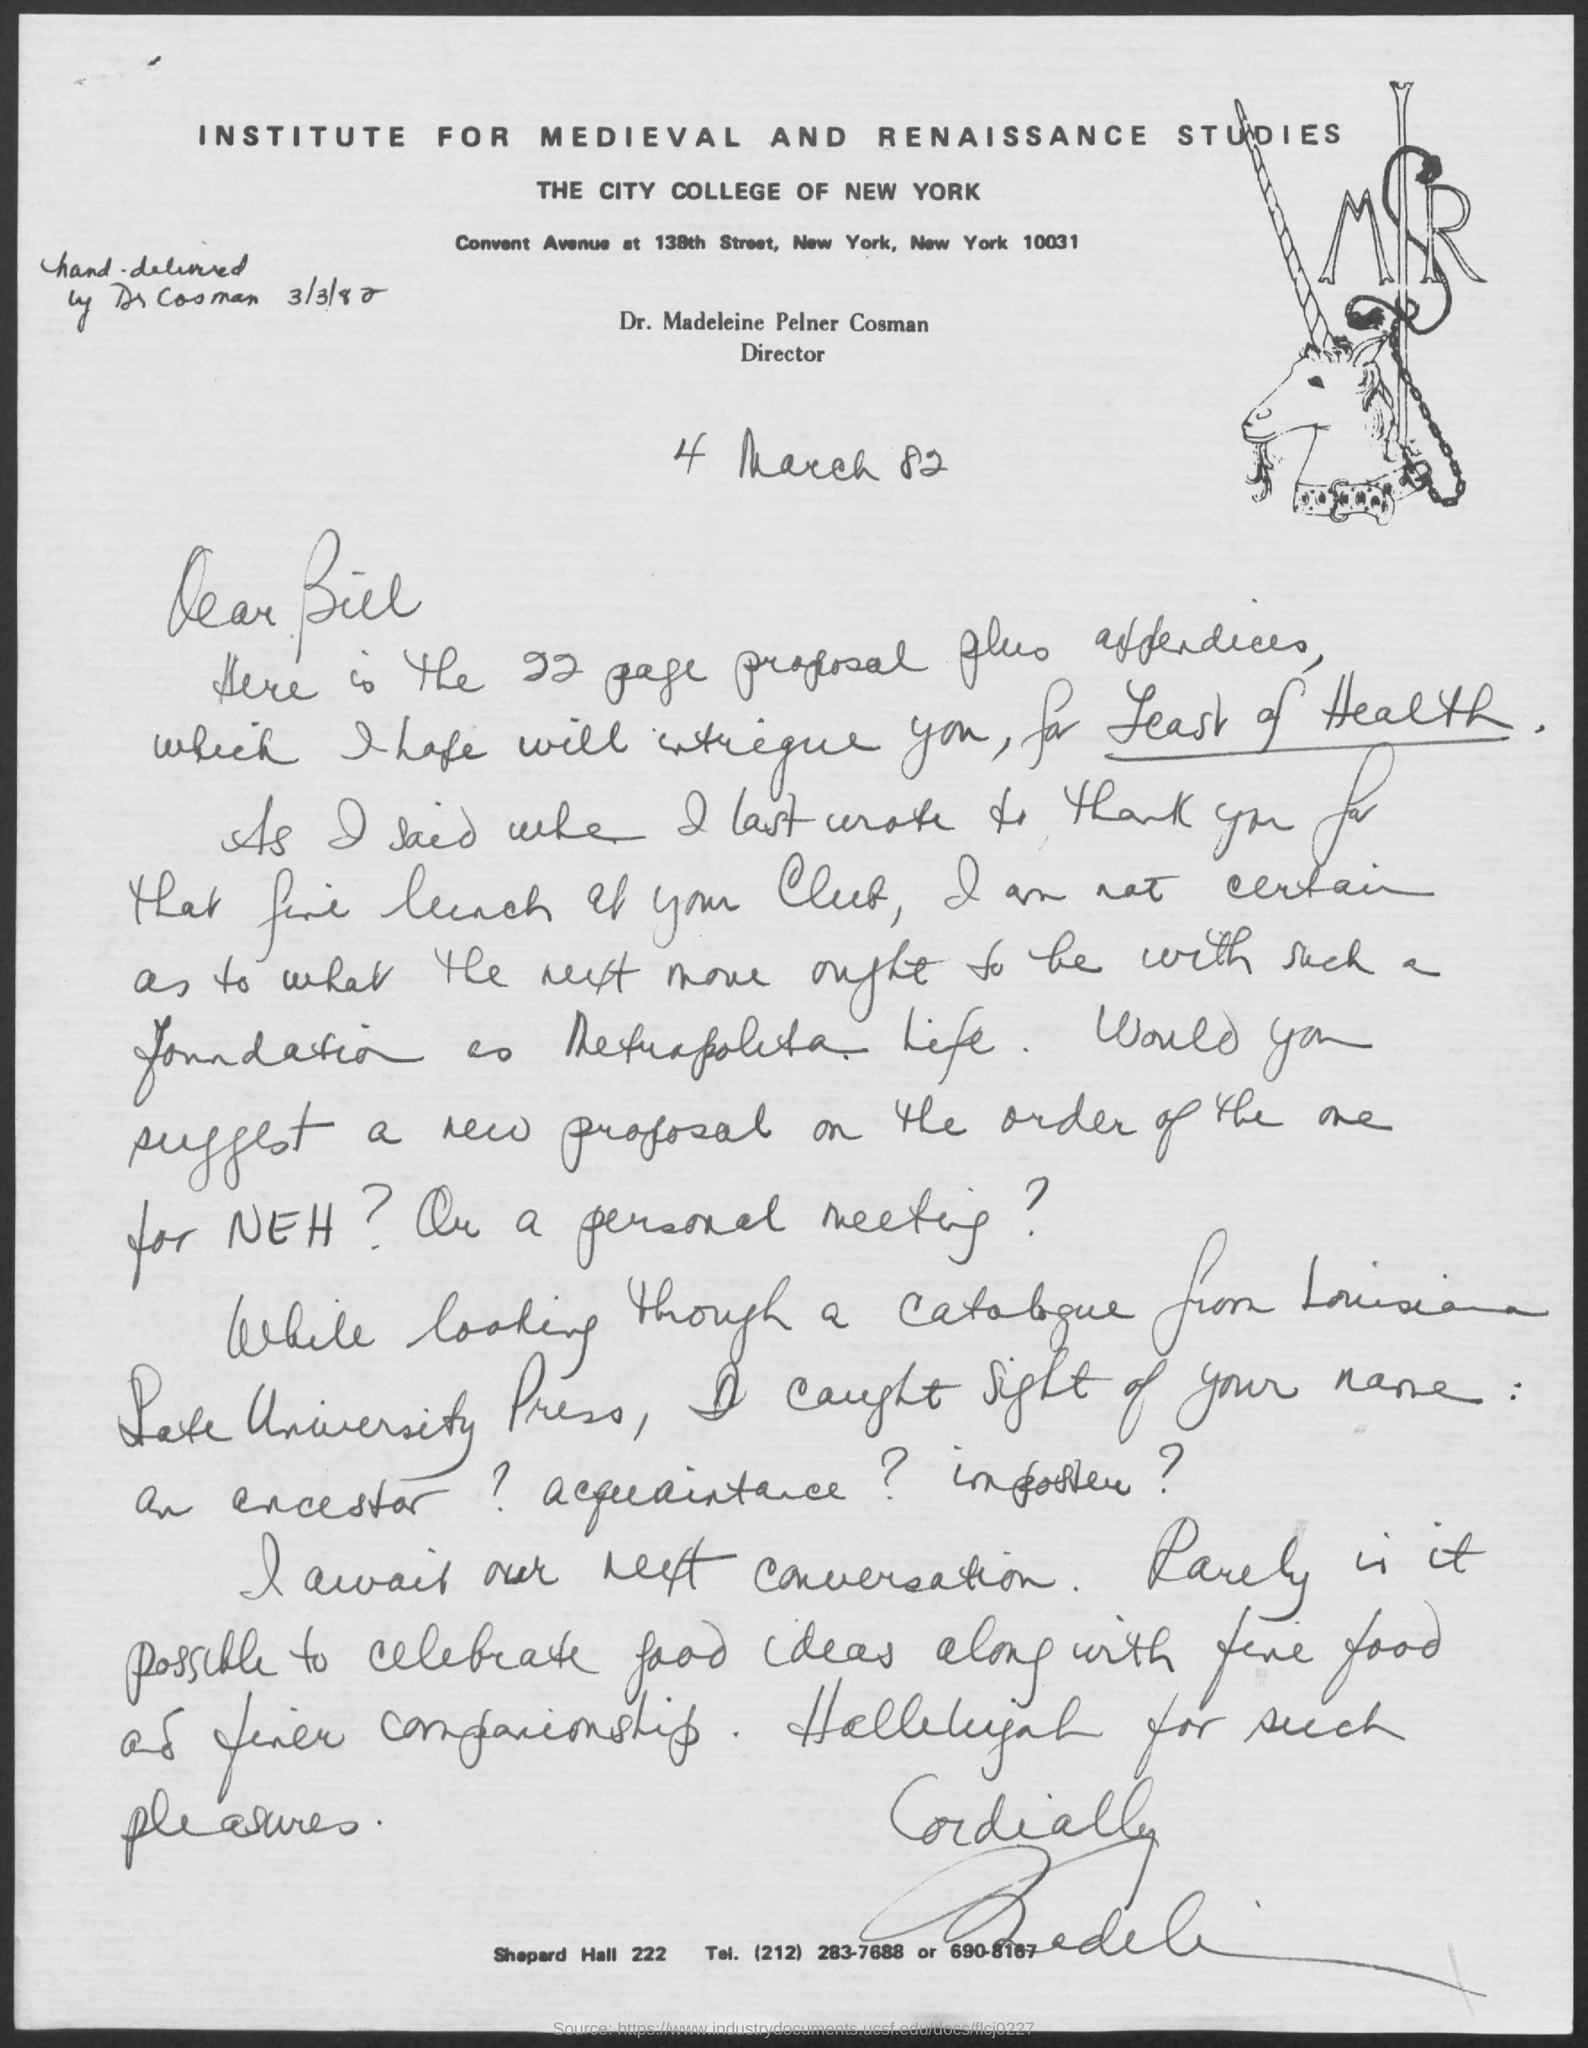Point out several critical features in this image. Dr. Cosman delivered the letter by hand on March 3, 1982. The Institute for Medieval and Renaissance Studies is mentioned at the top of the page. The City College of New York is mentioned in the text. Dr. Madeleine Pelner Cosman is the director. 